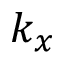<formula> <loc_0><loc_0><loc_500><loc_500>k _ { x }</formula> 